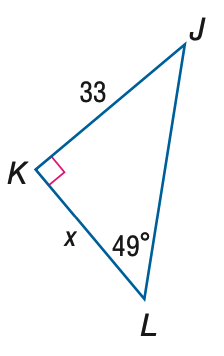Question: Find x. Round to the nearest tenth.
Choices:
A. 28.7
B. 38.0
C. 43.7
D. 50.3
Answer with the letter. Answer: A 